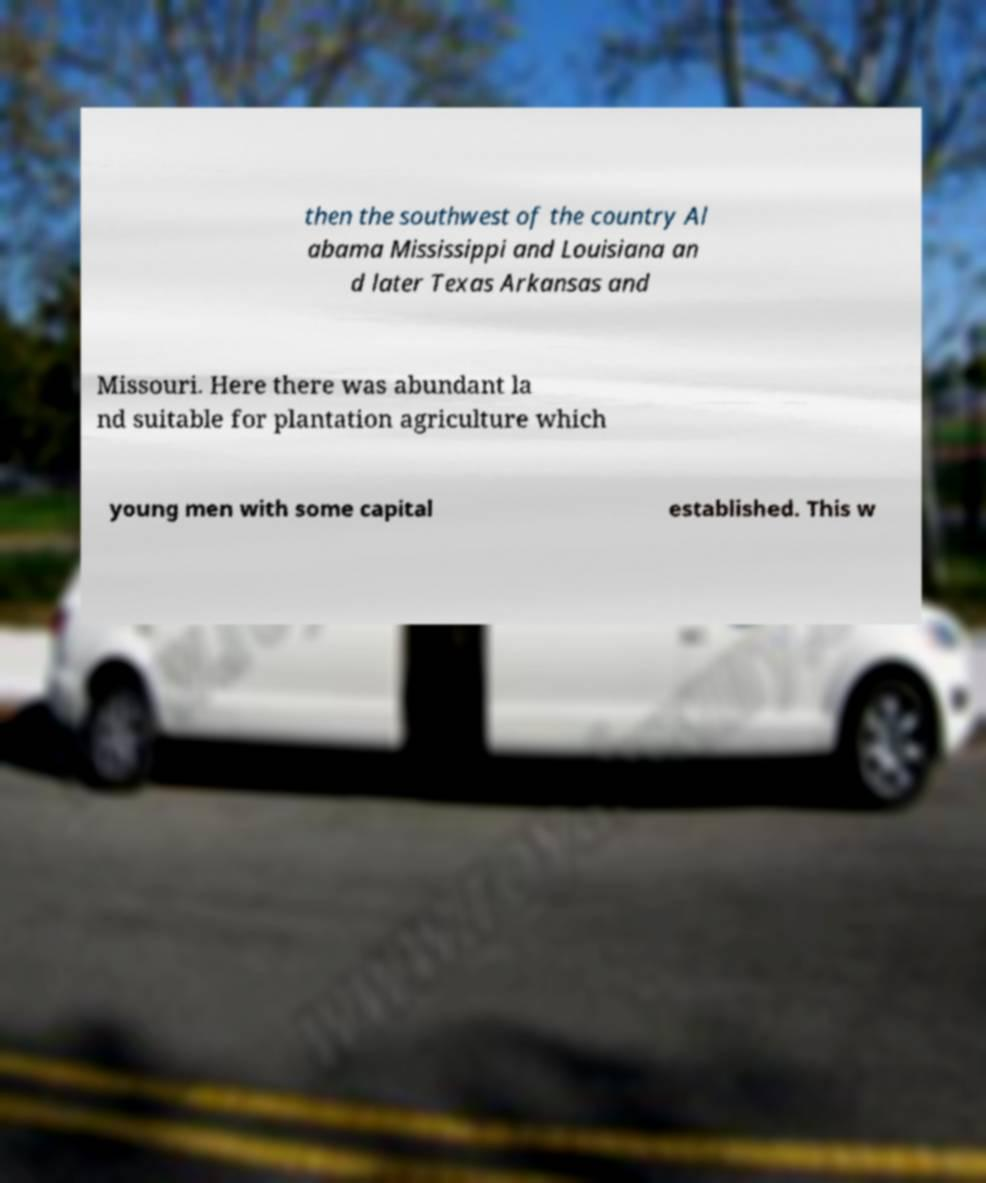Can you read and provide the text displayed in the image?This photo seems to have some interesting text. Can you extract and type it out for me? then the southwest of the country Al abama Mississippi and Louisiana an d later Texas Arkansas and Missouri. Here there was abundant la nd suitable for plantation agriculture which young men with some capital established. This w 